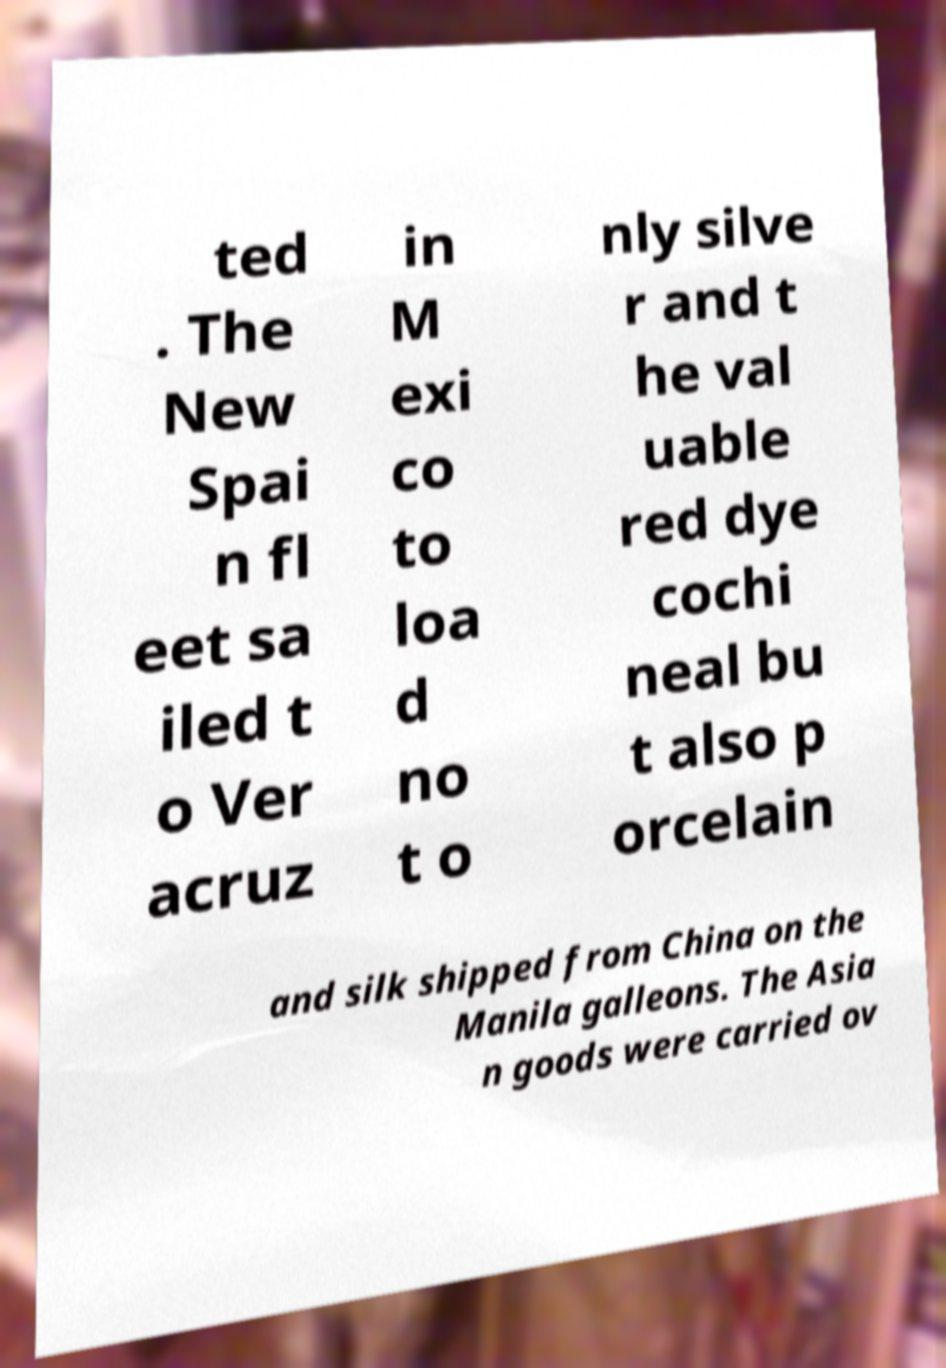There's text embedded in this image that I need extracted. Can you transcribe it verbatim? ted . The New Spai n fl eet sa iled t o Ver acruz in M exi co to loa d no t o nly silve r and t he val uable red dye cochi neal bu t also p orcelain and silk shipped from China on the Manila galleons. The Asia n goods were carried ov 